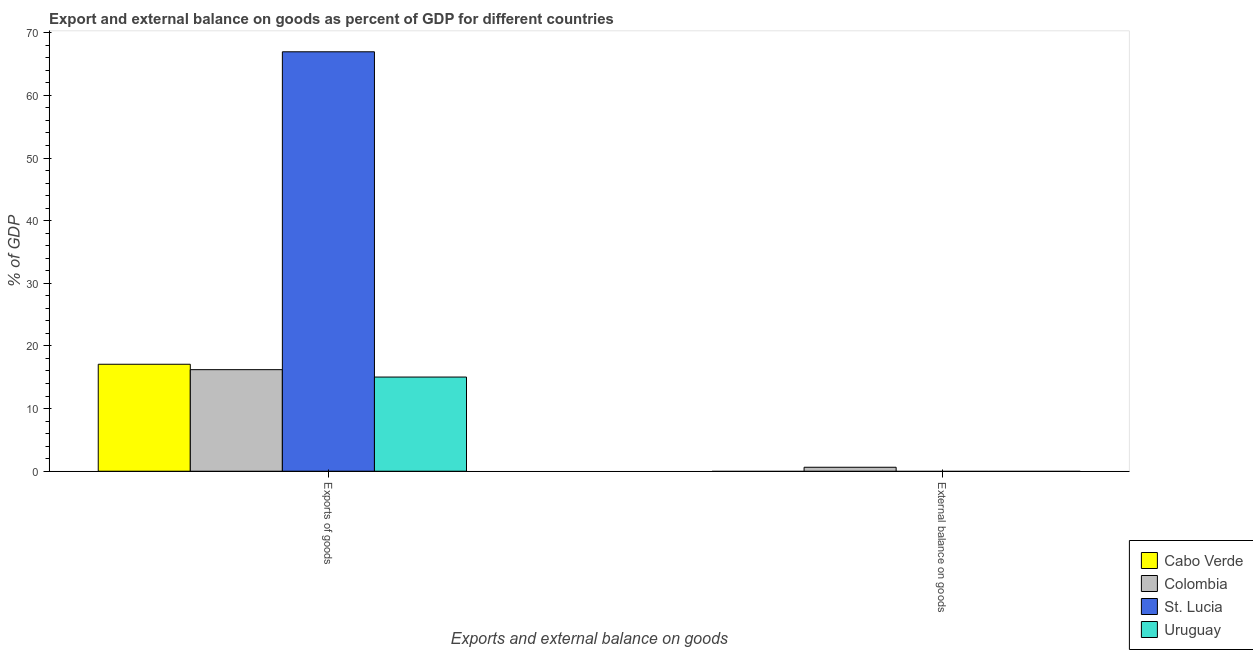How many bars are there on the 2nd tick from the right?
Provide a short and direct response. 4. What is the label of the 1st group of bars from the left?
Offer a terse response. Exports of goods. What is the export of goods as percentage of gdp in St. Lucia?
Your response must be concise. 66.96. Across all countries, what is the maximum external balance on goods as percentage of gdp?
Your answer should be compact. 0.63. What is the total export of goods as percentage of gdp in the graph?
Offer a very short reply. 115.28. What is the difference between the export of goods as percentage of gdp in St. Lucia and that in Uruguay?
Make the answer very short. 51.92. What is the difference between the export of goods as percentage of gdp in Uruguay and the external balance on goods as percentage of gdp in Colombia?
Offer a terse response. 14.4. What is the average external balance on goods as percentage of gdp per country?
Your answer should be compact. 0.16. What is the difference between the export of goods as percentage of gdp and external balance on goods as percentage of gdp in Colombia?
Make the answer very short. 15.58. In how many countries, is the external balance on goods as percentage of gdp greater than 26 %?
Give a very brief answer. 0. What is the ratio of the export of goods as percentage of gdp in Colombia to that in St. Lucia?
Offer a very short reply. 0.24. Is the export of goods as percentage of gdp in Colombia less than that in St. Lucia?
Provide a succinct answer. Yes. How many countries are there in the graph?
Your answer should be compact. 4. What is the difference between two consecutive major ticks on the Y-axis?
Provide a succinct answer. 10. Are the values on the major ticks of Y-axis written in scientific E-notation?
Provide a short and direct response. No. How many legend labels are there?
Give a very brief answer. 4. How are the legend labels stacked?
Give a very brief answer. Vertical. What is the title of the graph?
Offer a very short reply. Export and external balance on goods as percent of GDP for different countries. Does "Palau" appear as one of the legend labels in the graph?
Provide a succinct answer. No. What is the label or title of the X-axis?
Provide a short and direct response. Exports and external balance on goods. What is the label or title of the Y-axis?
Offer a very short reply. % of GDP. What is the % of GDP of Cabo Verde in Exports of goods?
Provide a succinct answer. 17.07. What is the % of GDP of Colombia in Exports of goods?
Your answer should be very brief. 16.21. What is the % of GDP of St. Lucia in Exports of goods?
Your response must be concise. 66.96. What is the % of GDP of Uruguay in Exports of goods?
Your answer should be very brief. 15.03. What is the % of GDP in Colombia in External balance on goods?
Offer a very short reply. 0.63. What is the % of GDP in Uruguay in External balance on goods?
Your answer should be very brief. 0. Across all Exports and external balance on goods, what is the maximum % of GDP of Cabo Verde?
Your answer should be very brief. 17.07. Across all Exports and external balance on goods, what is the maximum % of GDP of Colombia?
Keep it short and to the point. 16.21. Across all Exports and external balance on goods, what is the maximum % of GDP of St. Lucia?
Provide a succinct answer. 66.96. Across all Exports and external balance on goods, what is the maximum % of GDP of Uruguay?
Keep it short and to the point. 15.03. Across all Exports and external balance on goods, what is the minimum % of GDP of Colombia?
Offer a terse response. 0.63. Across all Exports and external balance on goods, what is the minimum % of GDP of St. Lucia?
Your answer should be very brief. 0. Across all Exports and external balance on goods, what is the minimum % of GDP in Uruguay?
Make the answer very short. 0. What is the total % of GDP in Cabo Verde in the graph?
Give a very brief answer. 17.07. What is the total % of GDP in Colombia in the graph?
Keep it short and to the point. 16.84. What is the total % of GDP of St. Lucia in the graph?
Your answer should be very brief. 66.96. What is the total % of GDP in Uruguay in the graph?
Provide a short and direct response. 15.03. What is the difference between the % of GDP of Colombia in Exports of goods and that in External balance on goods?
Give a very brief answer. 15.58. What is the difference between the % of GDP of Cabo Verde in Exports of goods and the % of GDP of Colombia in External balance on goods?
Offer a very short reply. 16.44. What is the average % of GDP in Cabo Verde per Exports and external balance on goods?
Provide a short and direct response. 8.54. What is the average % of GDP of Colombia per Exports and external balance on goods?
Your response must be concise. 8.42. What is the average % of GDP in St. Lucia per Exports and external balance on goods?
Make the answer very short. 33.48. What is the average % of GDP of Uruguay per Exports and external balance on goods?
Make the answer very short. 7.52. What is the difference between the % of GDP in Cabo Verde and % of GDP in Colombia in Exports of goods?
Provide a succinct answer. 0.86. What is the difference between the % of GDP in Cabo Verde and % of GDP in St. Lucia in Exports of goods?
Give a very brief answer. -49.88. What is the difference between the % of GDP in Cabo Verde and % of GDP in Uruguay in Exports of goods?
Offer a terse response. 2.04. What is the difference between the % of GDP of Colombia and % of GDP of St. Lucia in Exports of goods?
Provide a succinct answer. -50.74. What is the difference between the % of GDP of Colombia and % of GDP of Uruguay in Exports of goods?
Your answer should be very brief. 1.18. What is the difference between the % of GDP of St. Lucia and % of GDP of Uruguay in Exports of goods?
Make the answer very short. 51.92. What is the ratio of the % of GDP of Colombia in Exports of goods to that in External balance on goods?
Provide a short and direct response. 25.6. What is the difference between the highest and the second highest % of GDP of Colombia?
Keep it short and to the point. 15.58. What is the difference between the highest and the lowest % of GDP of Cabo Verde?
Provide a succinct answer. 17.07. What is the difference between the highest and the lowest % of GDP of Colombia?
Ensure brevity in your answer.  15.58. What is the difference between the highest and the lowest % of GDP in St. Lucia?
Provide a succinct answer. 66.96. What is the difference between the highest and the lowest % of GDP in Uruguay?
Ensure brevity in your answer.  15.03. 